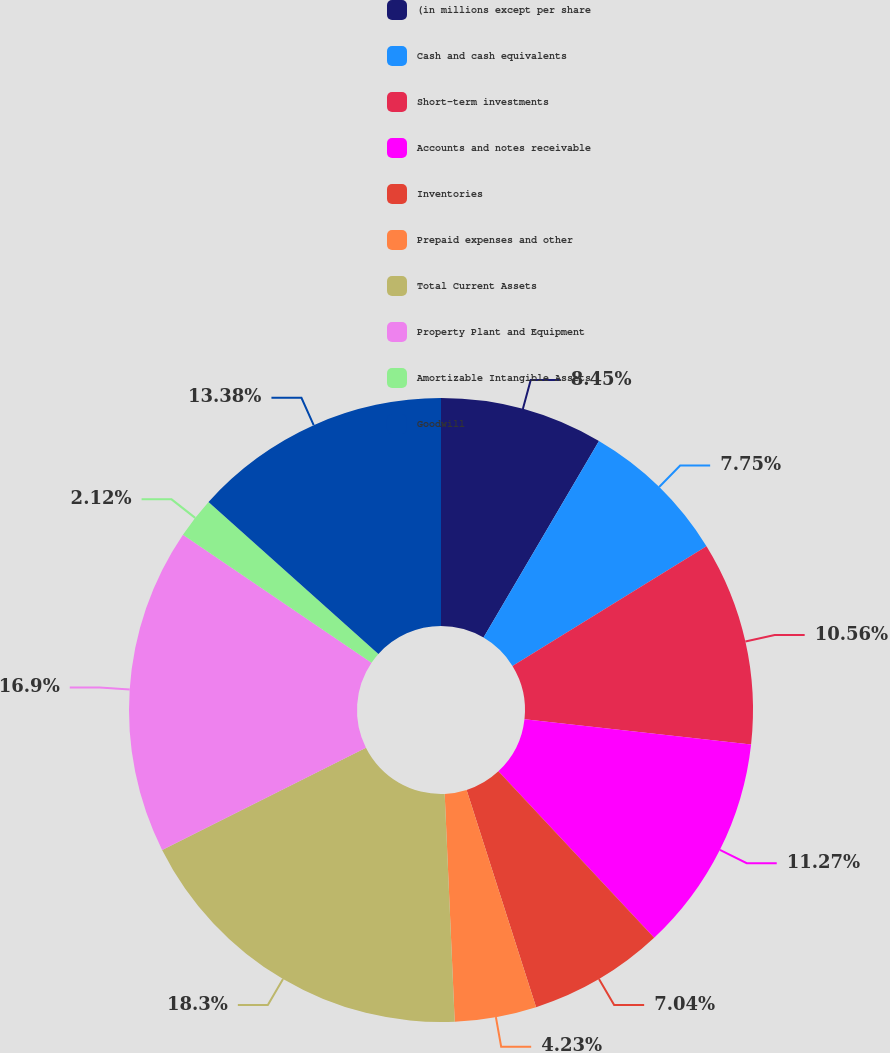Convert chart to OTSL. <chart><loc_0><loc_0><loc_500><loc_500><pie_chart><fcel>(in millions except per share<fcel>Cash and cash equivalents<fcel>Short-term investments<fcel>Accounts and notes receivable<fcel>Inventories<fcel>Prepaid expenses and other<fcel>Total Current Assets<fcel>Property Plant and Equipment<fcel>Amortizable Intangible Assets<fcel>Goodwill<nl><fcel>8.45%<fcel>7.75%<fcel>10.56%<fcel>11.27%<fcel>7.04%<fcel>4.23%<fcel>18.3%<fcel>16.9%<fcel>2.12%<fcel>13.38%<nl></chart> 